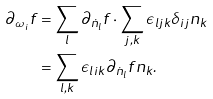<formula> <loc_0><loc_0><loc_500><loc_500>\partial _ { \omega _ { i } } f & = \sum _ { l } \partial _ { \dot { n } _ { l } } f \cdot \sum _ { j , k } \epsilon _ { l j k } \delta _ { i j } n _ { k } \\ & = \sum _ { l , k } \epsilon _ { l i k } \partial _ { \dot { n } _ { l } } f n _ { k } .</formula> 